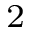Convert formula to latex. <formula><loc_0><loc_0><loc_500><loc_500>^ { 2 }</formula> 